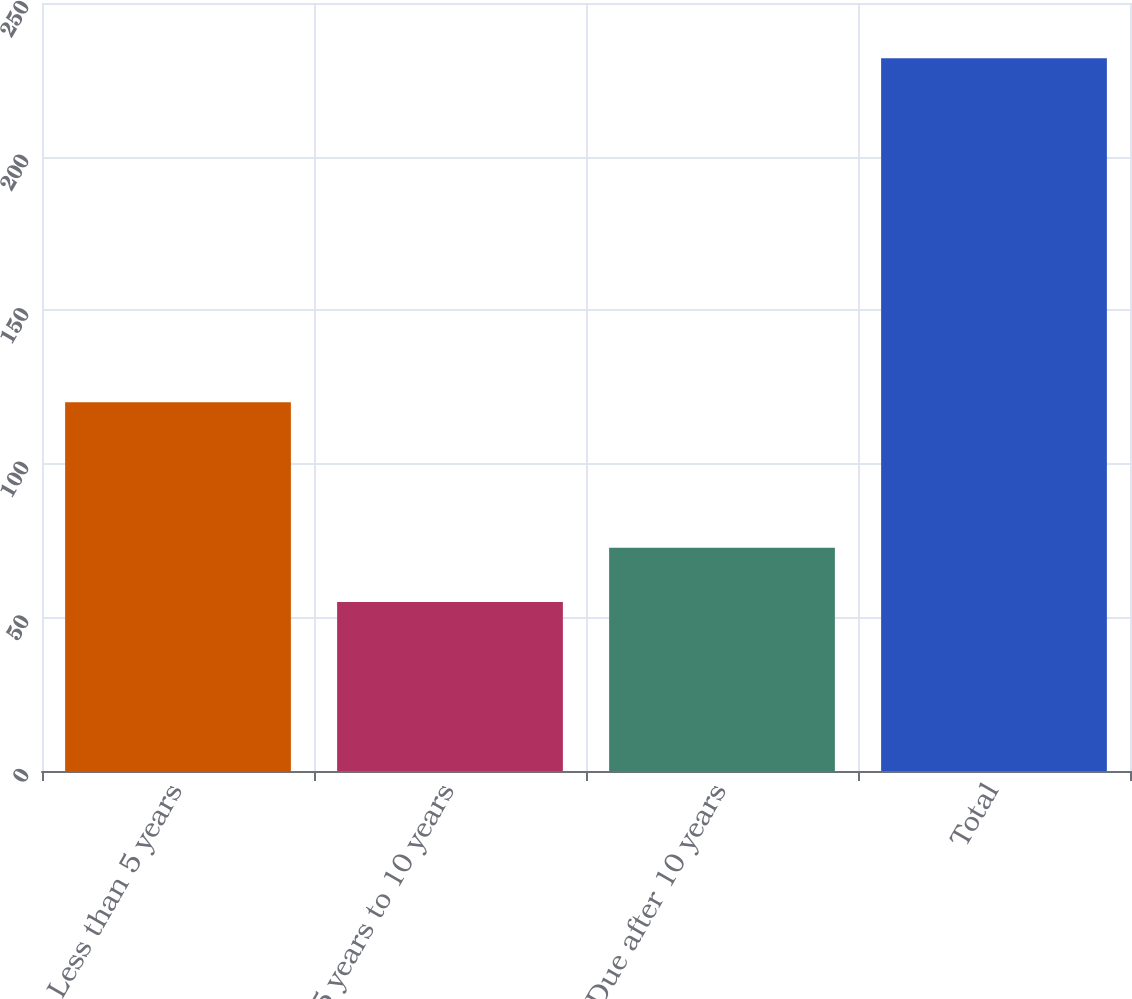<chart> <loc_0><loc_0><loc_500><loc_500><bar_chart><fcel>Less than 5 years<fcel>5 years to 10 years<fcel>Due after 10 years<fcel>Total<nl><fcel>120<fcel>55<fcel>72.7<fcel>232<nl></chart> 